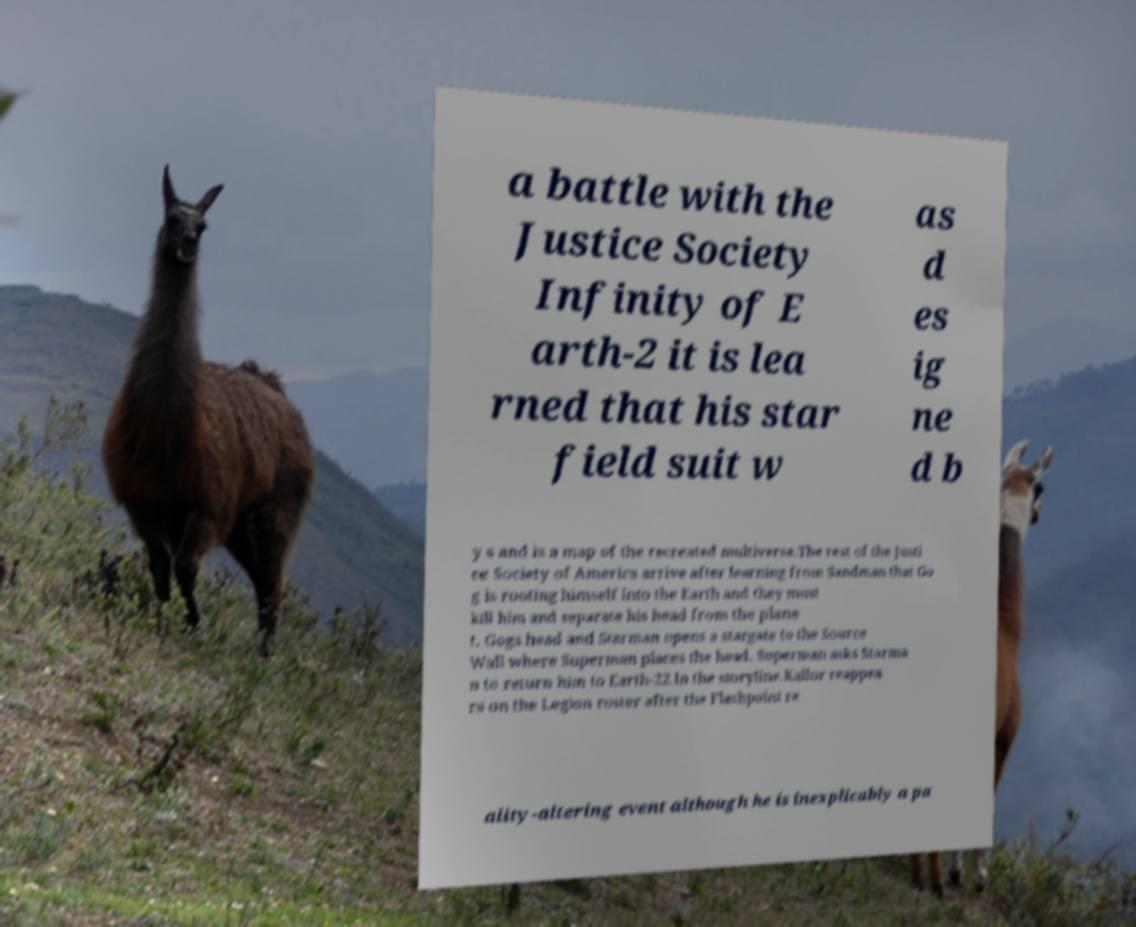What messages or text are displayed in this image? I need them in a readable, typed format. a battle with the Justice Society Infinity of E arth-2 it is lea rned that his star field suit w as d es ig ne d b y s and is a map of the recreated multiverse.The rest of the Justi ce Society of America arrive after learning from Sandman that Go g is rooting himself into the Earth and they must kill him and separate his head from the plane t. Gogs head and Starman opens a stargate to the Source Wall where Superman places the head. Superman asks Starma n to return him to Earth-22.In the storyline.Kallor reappea rs on the Legion roster after the Flashpoint re ality-altering event although he is inexplicably a pa 